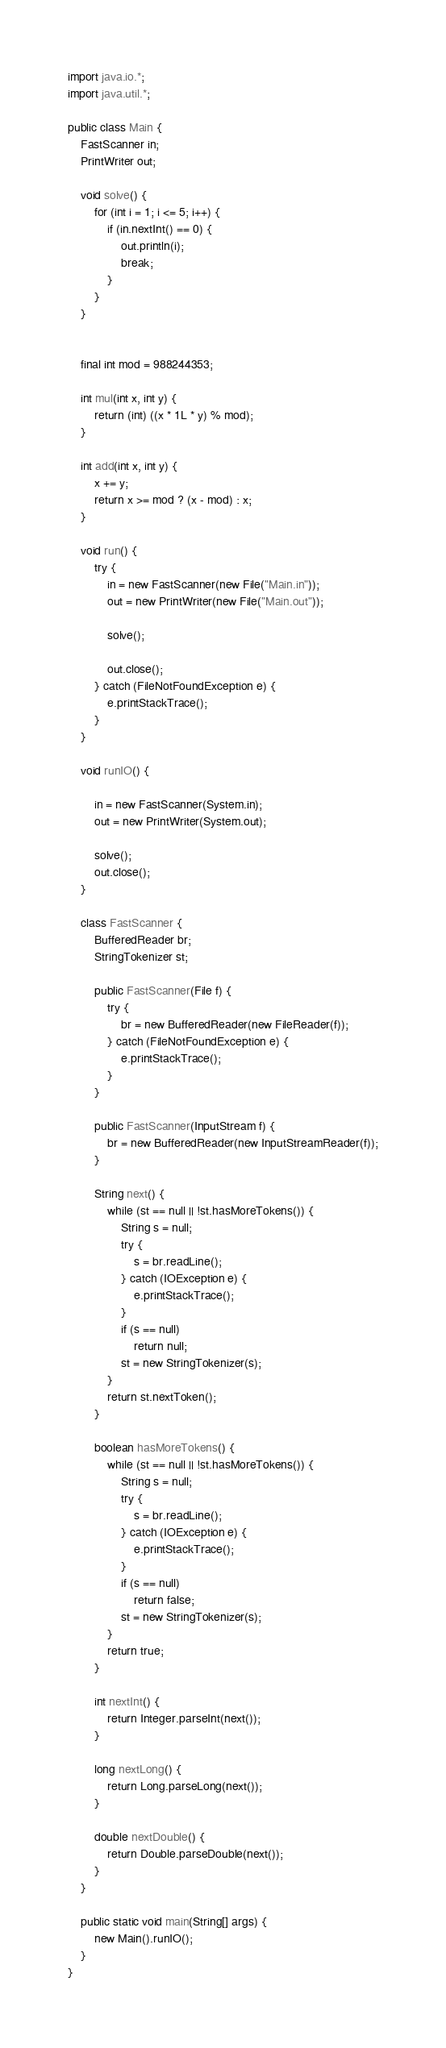<code> <loc_0><loc_0><loc_500><loc_500><_Java_>import java.io.*;
import java.util.*;

public class Main {
    FastScanner in;
    PrintWriter out;

    void solve() {
        for (int i = 1; i <= 5; i++) {
            if (in.nextInt() == 0) {
                out.println(i);
                break;
            }
        }
    }


    final int mod = 988244353;

    int mul(int x, int y) {
        return (int) ((x * 1L * y) % mod);
    }

    int add(int x, int y) {
        x += y;
        return x >= mod ? (x - mod) : x;
    }

    void run() {
        try {
            in = new FastScanner(new File("Main.in"));
            out = new PrintWriter(new File("Main.out"));

            solve();

            out.close();
        } catch (FileNotFoundException e) {
            e.printStackTrace();
        }
    }

    void runIO() {

        in = new FastScanner(System.in);
        out = new PrintWriter(System.out);

        solve();
        out.close();
    }

    class FastScanner {
        BufferedReader br;
        StringTokenizer st;

        public FastScanner(File f) {
            try {
                br = new BufferedReader(new FileReader(f));
            } catch (FileNotFoundException e) {
                e.printStackTrace();
            }
        }

        public FastScanner(InputStream f) {
            br = new BufferedReader(new InputStreamReader(f));
        }

        String next() {
            while (st == null || !st.hasMoreTokens()) {
                String s = null;
                try {
                    s = br.readLine();
                } catch (IOException e) {
                    e.printStackTrace();
                }
                if (s == null)
                    return null;
                st = new StringTokenizer(s);
            }
            return st.nextToken();
        }

        boolean hasMoreTokens() {
            while (st == null || !st.hasMoreTokens()) {
                String s = null;
                try {
                    s = br.readLine();
                } catch (IOException e) {
                    e.printStackTrace();
                }
                if (s == null)
                    return false;
                st = new StringTokenizer(s);
            }
            return true;
        }

        int nextInt() {
            return Integer.parseInt(next());
        }

        long nextLong() {
            return Long.parseLong(next());
        }

        double nextDouble() {
            return Double.parseDouble(next());
        }
    }

    public static void main(String[] args) {
        new Main().runIO();
    }
}</code> 